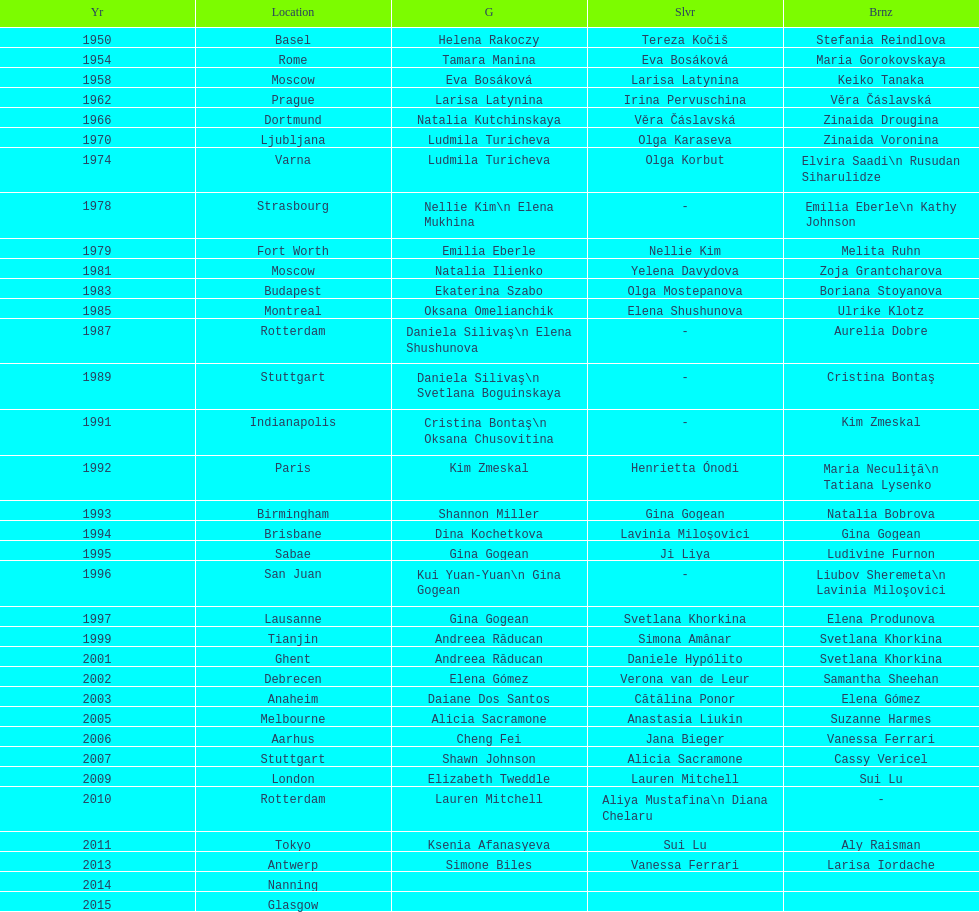Write the full table. {'header': ['Yr', 'Location', 'G', 'Slvr', 'Brnz'], 'rows': [['1950', 'Basel', 'Helena Rakoczy', 'Tereza Kočiš', 'Stefania Reindlova'], ['1954', 'Rome', 'Tamara Manina', 'Eva Bosáková', 'Maria Gorokovskaya'], ['1958', 'Moscow', 'Eva Bosáková', 'Larisa Latynina', 'Keiko Tanaka'], ['1962', 'Prague', 'Larisa Latynina', 'Irina Pervuschina', 'Věra Čáslavská'], ['1966', 'Dortmund', 'Natalia Kutchinskaya', 'Věra Čáslavská', 'Zinaida Drougina'], ['1970', 'Ljubljana', 'Ludmila Turicheva', 'Olga Karaseva', 'Zinaida Voronina'], ['1974', 'Varna', 'Ludmila Turicheva', 'Olga Korbut', 'Elvira Saadi\\n Rusudan Siharulidze'], ['1978', 'Strasbourg', 'Nellie Kim\\n Elena Mukhina', '-', 'Emilia Eberle\\n Kathy Johnson'], ['1979', 'Fort Worth', 'Emilia Eberle', 'Nellie Kim', 'Melita Ruhn'], ['1981', 'Moscow', 'Natalia Ilienko', 'Yelena Davydova', 'Zoja Grantcharova'], ['1983', 'Budapest', 'Ekaterina Szabo', 'Olga Mostepanova', 'Boriana Stoyanova'], ['1985', 'Montreal', 'Oksana Omelianchik', 'Elena Shushunova', 'Ulrike Klotz'], ['1987', 'Rotterdam', 'Daniela Silivaş\\n Elena Shushunova', '-', 'Aurelia Dobre'], ['1989', 'Stuttgart', 'Daniela Silivaş\\n Svetlana Boguinskaya', '-', 'Cristina Bontaş'], ['1991', 'Indianapolis', 'Cristina Bontaş\\n Oksana Chusovitina', '-', 'Kim Zmeskal'], ['1992', 'Paris', 'Kim Zmeskal', 'Henrietta Ónodi', 'Maria Neculiţă\\n Tatiana Lysenko'], ['1993', 'Birmingham', 'Shannon Miller', 'Gina Gogean', 'Natalia Bobrova'], ['1994', 'Brisbane', 'Dina Kochetkova', 'Lavinia Miloşovici', 'Gina Gogean'], ['1995', 'Sabae', 'Gina Gogean', 'Ji Liya', 'Ludivine Furnon'], ['1996', 'San Juan', 'Kui Yuan-Yuan\\n Gina Gogean', '-', 'Liubov Sheremeta\\n Lavinia Miloşovici'], ['1997', 'Lausanne', 'Gina Gogean', 'Svetlana Khorkina', 'Elena Produnova'], ['1999', 'Tianjin', 'Andreea Răducan', 'Simona Amânar', 'Svetlana Khorkina'], ['2001', 'Ghent', 'Andreea Răducan', 'Daniele Hypólito', 'Svetlana Khorkina'], ['2002', 'Debrecen', 'Elena Gómez', 'Verona van de Leur', 'Samantha Sheehan'], ['2003', 'Anaheim', 'Daiane Dos Santos', 'Cătălina Ponor', 'Elena Gómez'], ['2005', 'Melbourne', 'Alicia Sacramone', 'Anastasia Liukin', 'Suzanne Harmes'], ['2006', 'Aarhus', 'Cheng Fei', 'Jana Bieger', 'Vanessa Ferrari'], ['2007', 'Stuttgart', 'Shawn Johnson', 'Alicia Sacramone', 'Cassy Vericel'], ['2009', 'London', 'Elizabeth Tweddle', 'Lauren Mitchell', 'Sui Lu'], ['2010', 'Rotterdam', 'Lauren Mitchell', 'Aliya Mustafina\\n Diana Chelaru', '-'], ['2011', 'Tokyo', 'Ksenia Afanasyeva', 'Sui Lu', 'Aly Raisman'], ['2013', 'Antwerp', 'Simone Biles', 'Vanessa Ferrari', 'Larisa Iordache'], ['2014', 'Nanning', '', '', ''], ['2015', 'Glasgow', '', '', '']]} Where were the championships held before the 1962 prague championships? Moscow. 